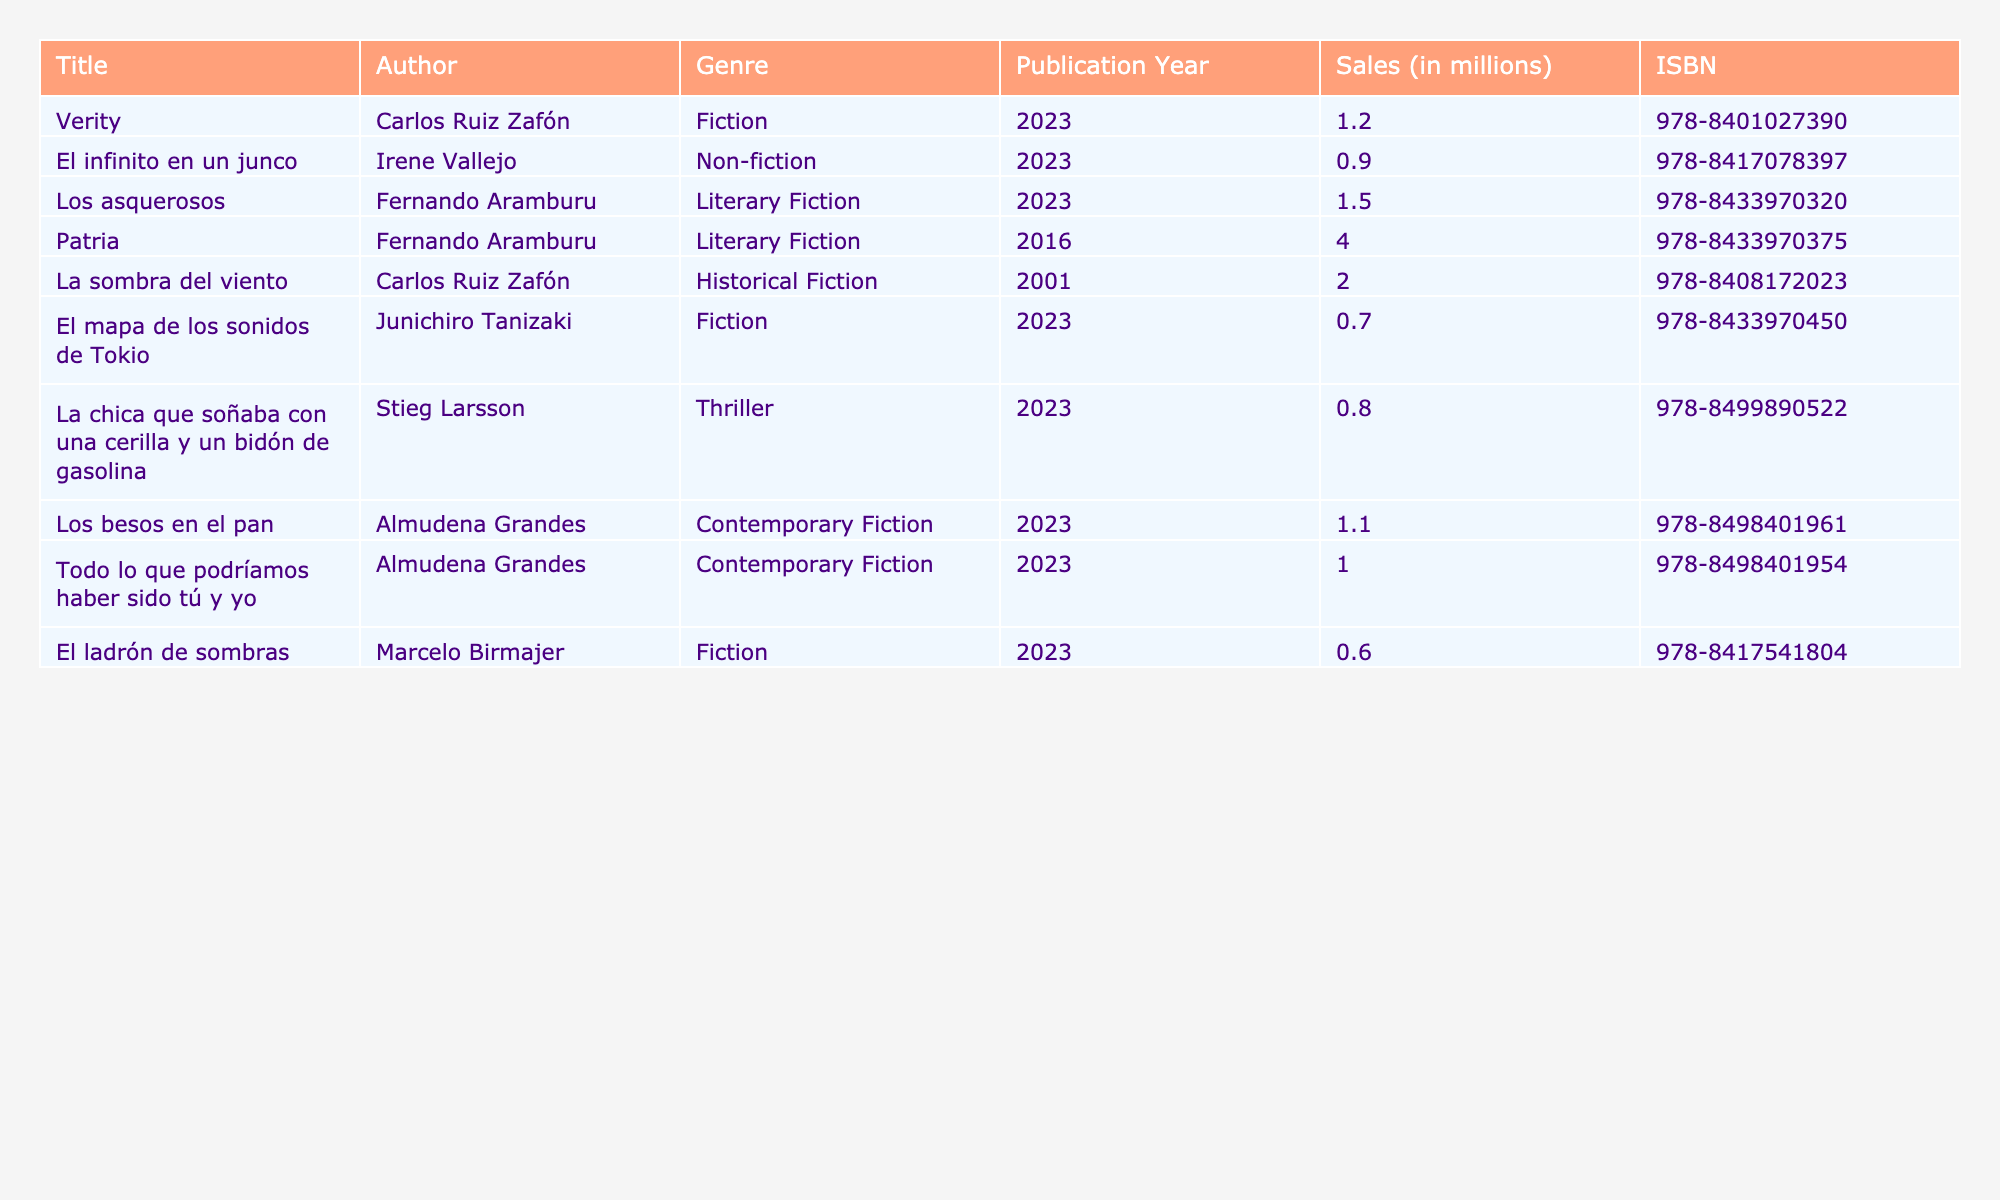What is the title of the book with the highest sales in 2023? The book with the highest sales figures listed in the table for 2023 is "Los asquerosos" by Fernando Aramburu. It has sales of 1.5 million.
Answer: "Los asquerosos" Which author has published two top-selling books in 2023? The author Fernando Aramburu has two books listed as top-selling in 2023: "Los asquerosos" with 1.5 million sales and "Patria," though "Patria" was published in 2016 and isn't considered for 2023 sales. So, the answer is he has one top-selling book in that year.
Answer: False What is the total sales of all the books listed for 2023? To find the total sales for 2023, we sum the sales of all books published that year: (1.2 + 0.9 + 1.5 + 0.7 + 0.8 + 1.1 + 1.0 + 0.6) = 6.8 million.
Answer: 6.8 million Is "El infinito en un junco" a work of fiction? The table categorizes "El infinito en un junco" as Non-fiction, implying it is not a work of fiction, so this statement is false.
Answer: False How many books in the table have a genre of Fiction? The table lists three books under the genre of Fiction: "Verity," "El mapa de los sonidos de Tokio," and "El ladrón de sombras." That's a total of three books.
Answer: 3 What is the average sales of the books by Almudena Grandes for 2023? There are two books by Almudena Grandes: "Los besos en el pan" with 1.1 million sales and "Todo lo que podríamos haber sido tú y yo" with 1.0 million sales. The average is calculated as (1.1 + 1.0) / 2 = 1.05 million.
Answer: 1.05 million Which book has the lowest sales in 2023, and what is its sales figure? By examining the sales column, "El ladrón de sombras" by Marcelo Birmajer has the lowest sales figure at 0.6 million.
Answer: "El ladrón de sombras," 0.6 million Are there more works of Literary Fiction or Contemporary Fiction listed in the table? The table lists two Literary Fiction works: "Los asquerosos" and "Patria," while it lists two Contemporary Fiction books: "Los besos en el pan" and "Todo lo que podríamos haber sido tú y yo." Both genres have the same count.
Answer: No, they are equal 